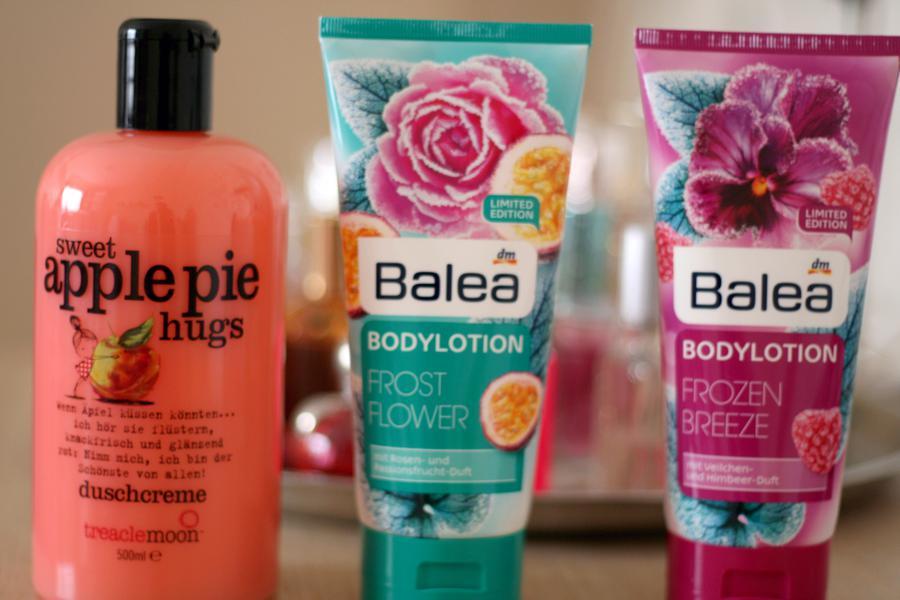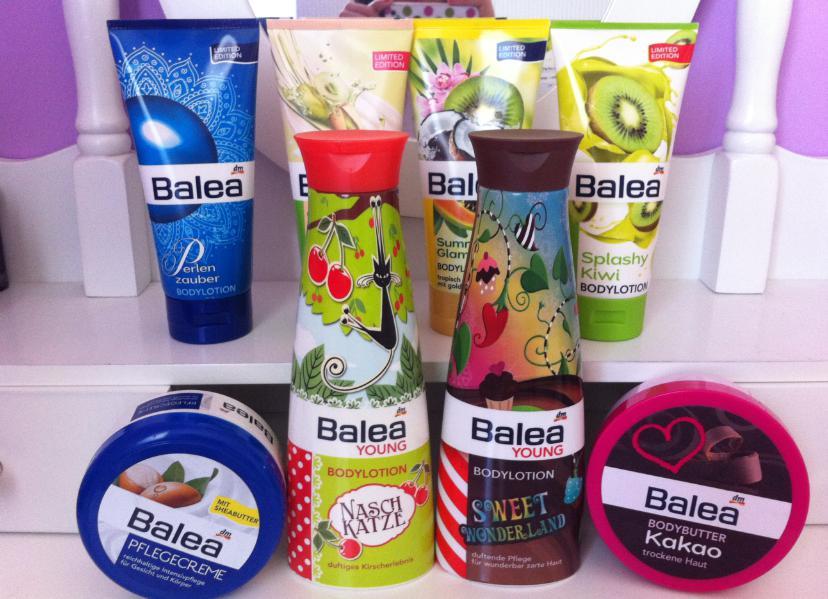The first image is the image on the left, the second image is the image on the right. Analyze the images presented: Is the assertion "The shelf holding some of the items is not visible." valid? Answer yes or no. No. The first image is the image on the left, the second image is the image on the right. Examine the images to the left and right. Is the description "The image on the right contains both a blue and a red circular container." accurate? Answer yes or no. Yes. 